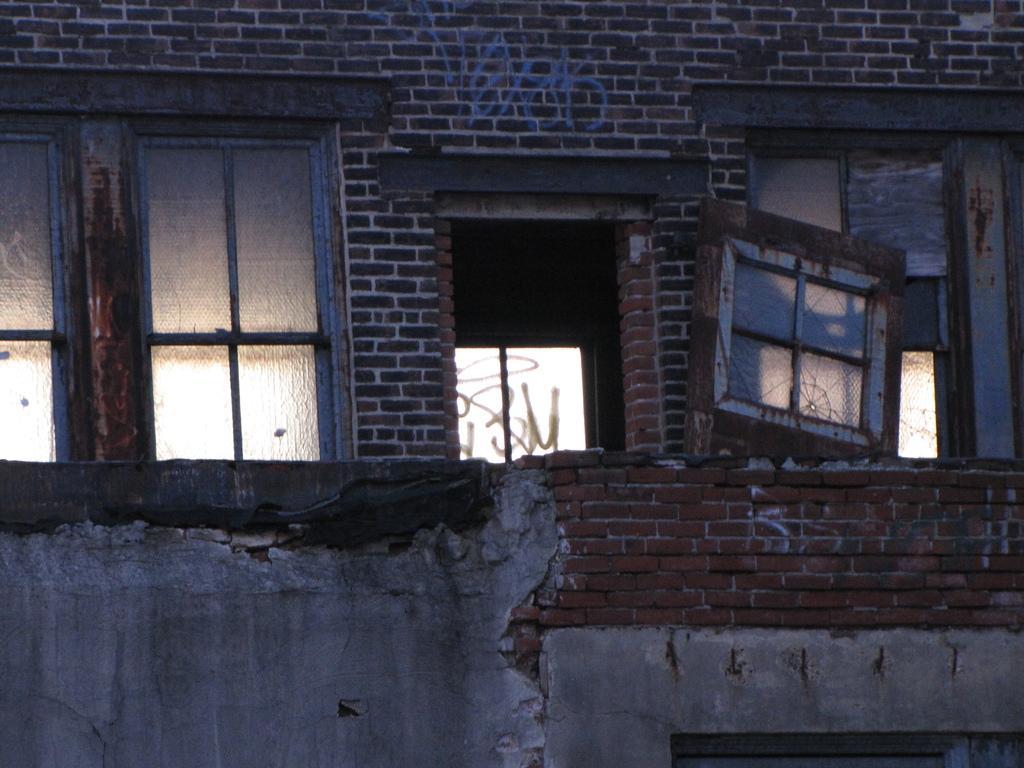Please provide a concise description of this image. In this image we can see an outside view of a building on which we can see group of windows and a door. 